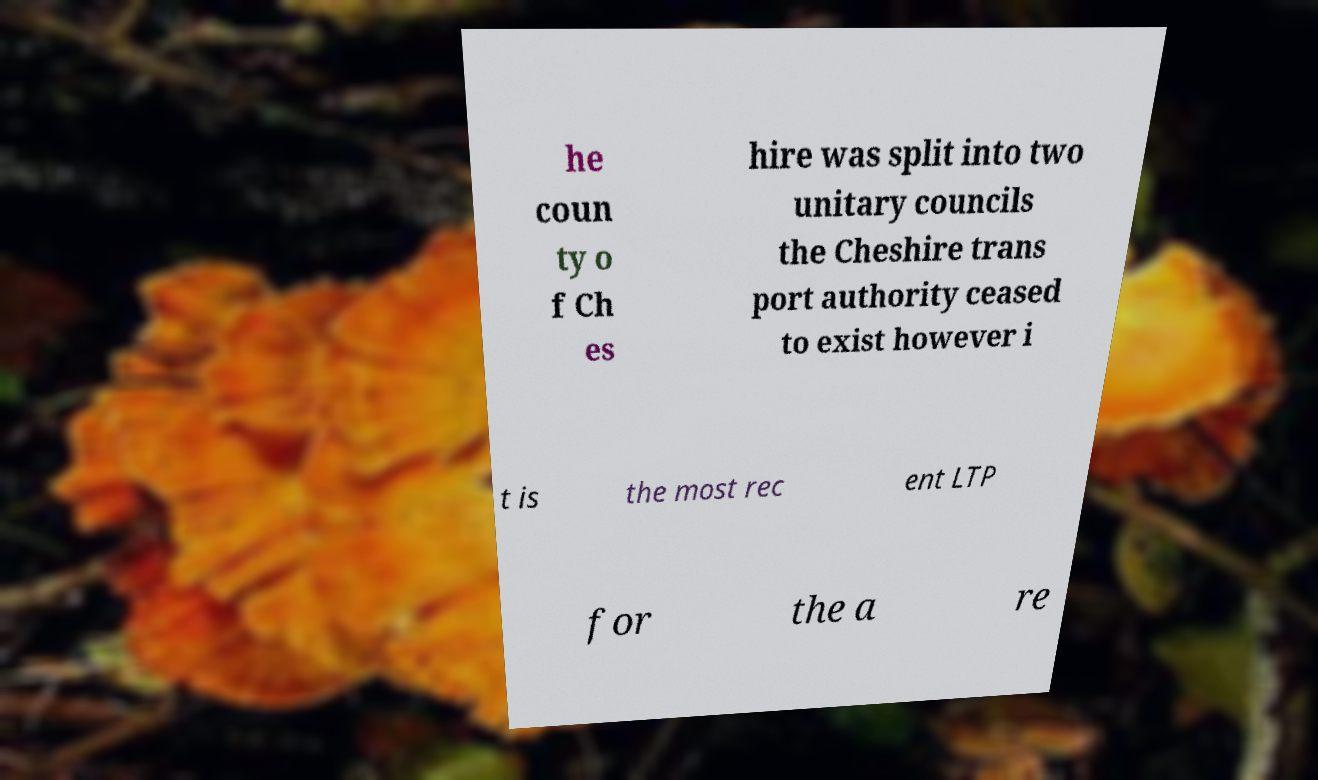Could you assist in decoding the text presented in this image and type it out clearly? he coun ty o f Ch es hire was split into two unitary councils the Cheshire trans port authority ceased to exist however i t is the most rec ent LTP for the a re 